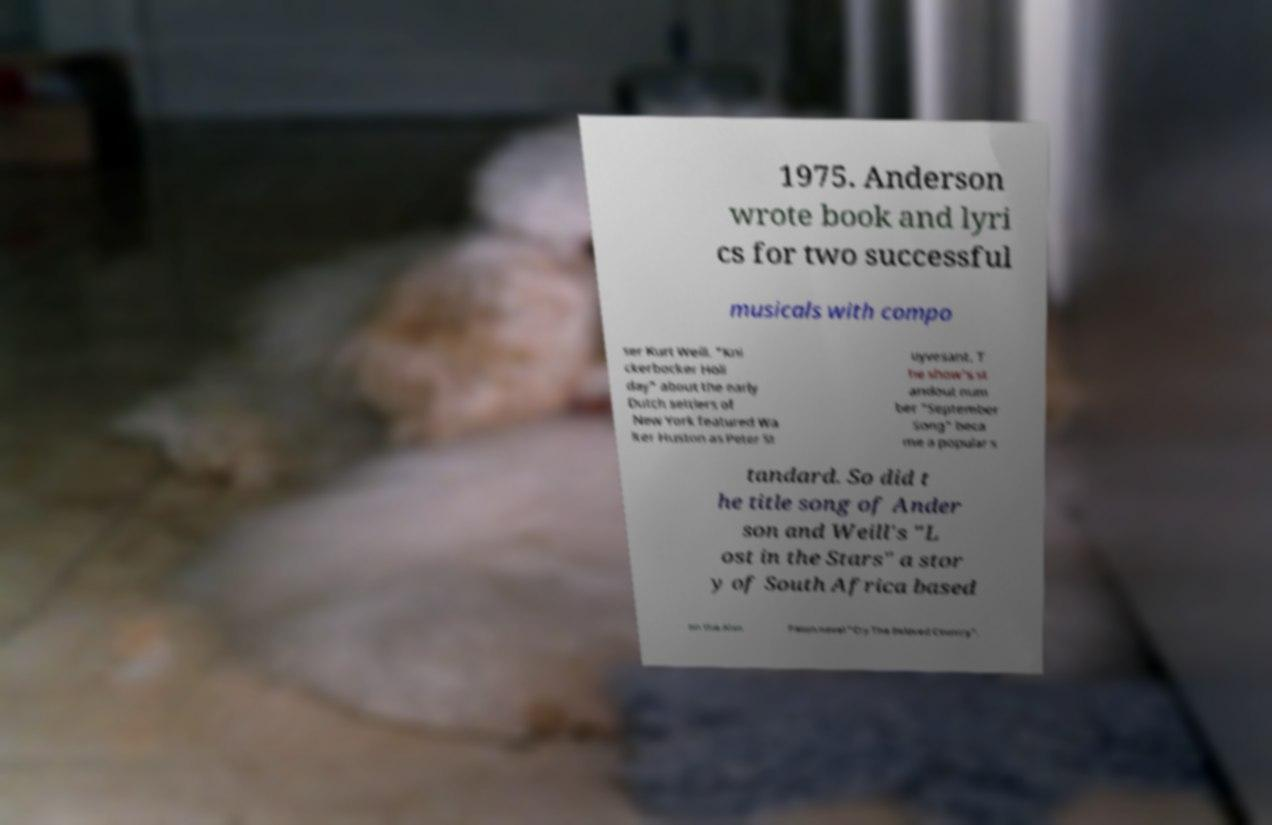What messages or text are displayed in this image? I need them in a readable, typed format. 1975. Anderson wrote book and lyri cs for two successful musicals with compo ser Kurt Weill. "Kni ckerbocker Holi day" about the early Dutch settlers of New York featured Wa lter Huston as Peter St uyvesant. T he show's st andout num ber "September Song" beca me a popular s tandard. So did t he title song of Ander son and Weill's "L ost in the Stars" a stor y of South Africa based on the Alan Paton novel "Cry The Beloved Country". 